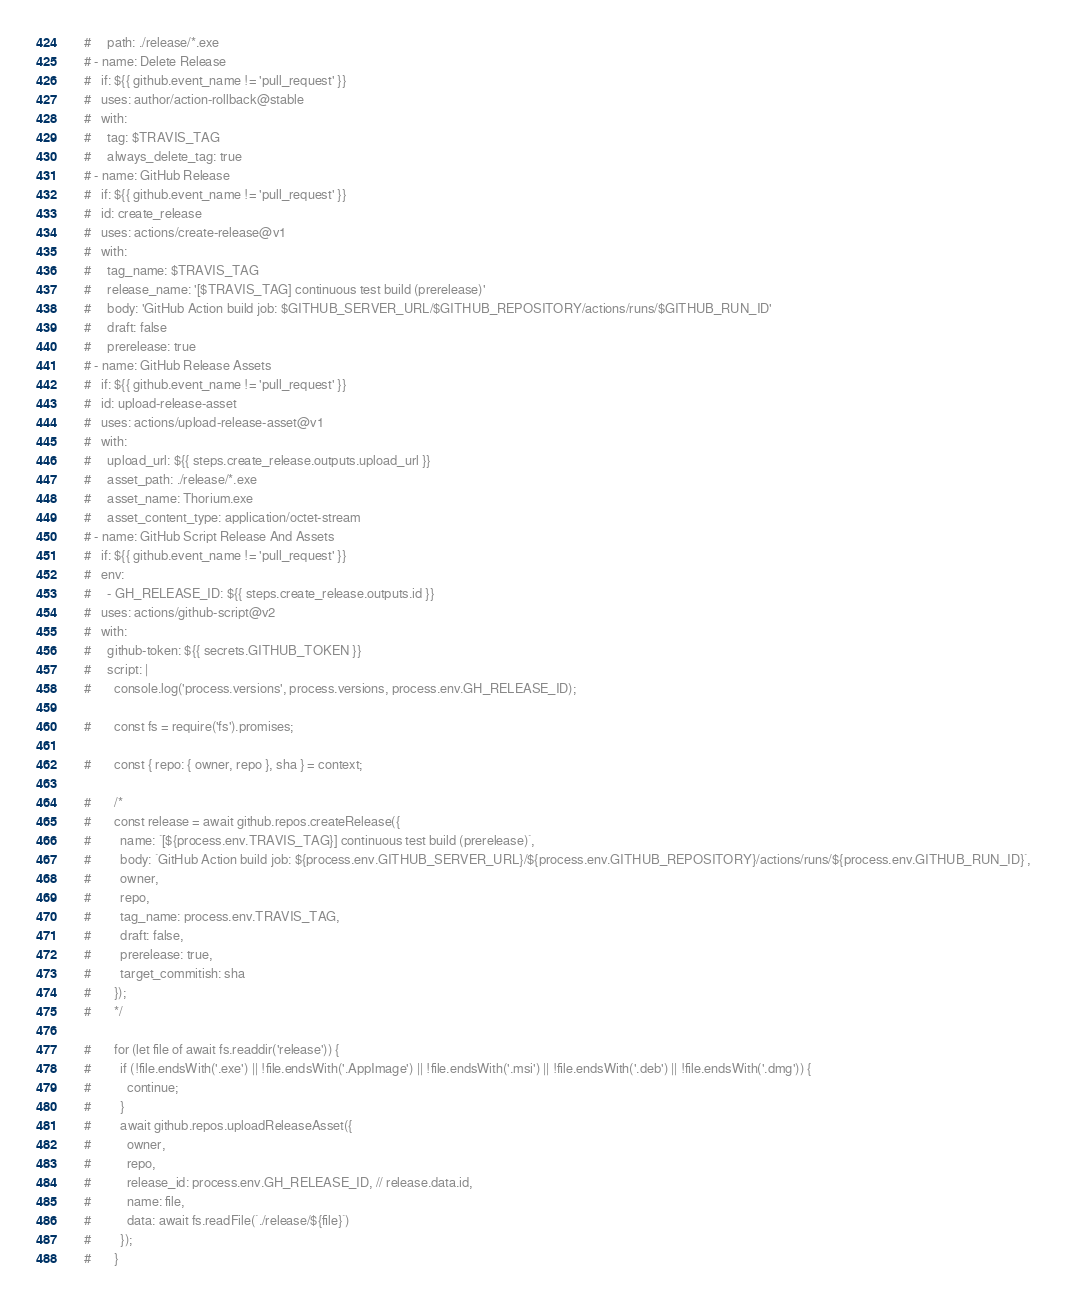Convert code to text. <code><loc_0><loc_0><loc_500><loc_500><_YAML_>    #     path: ./release/*.exe
    # - name: Delete Release
    #   if: ${{ github.event_name != 'pull_request' }}
    #   uses: author/action-rollback@stable
    #   with:
    #     tag: $TRAVIS_TAG
    #     always_delete_tag: true
    # - name: GitHub Release
    #   if: ${{ github.event_name != 'pull_request' }}
    #   id: create_release
    #   uses: actions/create-release@v1
    #   with:
    #     tag_name: $TRAVIS_TAG
    #     release_name: '[$TRAVIS_TAG] continuous test build (prerelease)'
    #     body: 'GitHub Action build job: $GITHUB_SERVER_URL/$GITHUB_REPOSITORY/actions/runs/$GITHUB_RUN_ID'
    #     draft: false
    #     prerelease: true
    # - name: GitHub Release Assets
    #   if: ${{ github.event_name != 'pull_request' }}
    #   id: upload-release-asset
    #   uses: actions/upload-release-asset@v1
    #   with:
    #     upload_url: ${{ steps.create_release.outputs.upload_url }}
    #     asset_path: ./release/*.exe
    #     asset_name: Thorium.exe
    #     asset_content_type: application/octet-stream
    # - name: GitHub Script Release And Assets
    #   if: ${{ github.event_name != 'pull_request' }}
    #   env:
    #     - GH_RELEASE_ID: ${{ steps.create_release.outputs.id }}
    #   uses: actions/github-script@v2
    #   with:
    #     github-token: ${{ secrets.GITHUB_TOKEN }}
    #     script: |
    #       console.log('process.versions', process.versions, process.env.GH_RELEASE_ID);

    #       const fs = require('fs').promises;

    #       const { repo: { owner, repo }, sha } = context;

    #       /*
    #       const release = await github.repos.createRelease({
    #         name: `[${process.env.TRAVIS_TAG}] continuous test build (prerelease)`,
    #         body: `GitHub Action build job: ${process.env.GITHUB_SERVER_URL}/${process.env.GITHUB_REPOSITORY}/actions/runs/${process.env.GITHUB_RUN_ID}`,
    #         owner,
    #         repo,
    #         tag_name: process.env.TRAVIS_TAG,
    #         draft: false,
    #         prerelease: true,
    #         target_commitish: sha
    #       });
    #       */

    #       for (let file of await fs.readdir('release')) {
    #         if (!file.endsWith('.exe') || !file.endsWith('.AppImage') || !file.endsWith('.msi') || !file.endsWith('.deb') || !file.endsWith('.dmg')) {
    #           continue;
    #         }
    #         await github.repos.uploadReleaseAsset({
    #           owner,
    #           repo,
    #           release_id: process.env.GH_RELEASE_ID, // release.data.id,
    #           name: file,
    #           data: await fs.readFile(`./release/${file}`)
    #         });
    #       }
</code> 